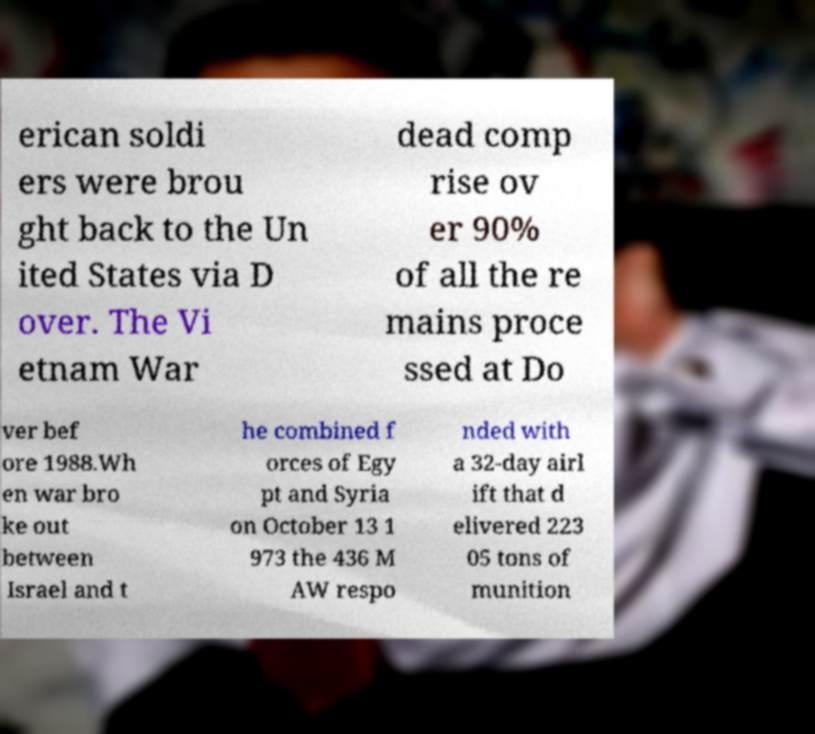Can you accurately transcribe the text from the provided image for me? erican soldi ers were brou ght back to the Un ited States via D over. The Vi etnam War dead comp rise ov er 90% of all the re mains proce ssed at Do ver bef ore 1988.Wh en war bro ke out between Israel and t he combined f orces of Egy pt and Syria on October 13 1 973 the 436 M AW respo nded with a 32-day airl ift that d elivered 223 05 tons of munition 